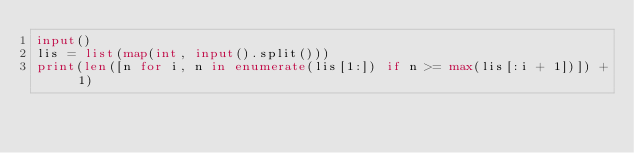<code> <loc_0><loc_0><loc_500><loc_500><_Python_>input()
lis = list(map(int, input().split()))
print(len([n for i, n in enumerate(lis[1:]) if n >= max(lis[:i + 1])]) + 1)</code> 